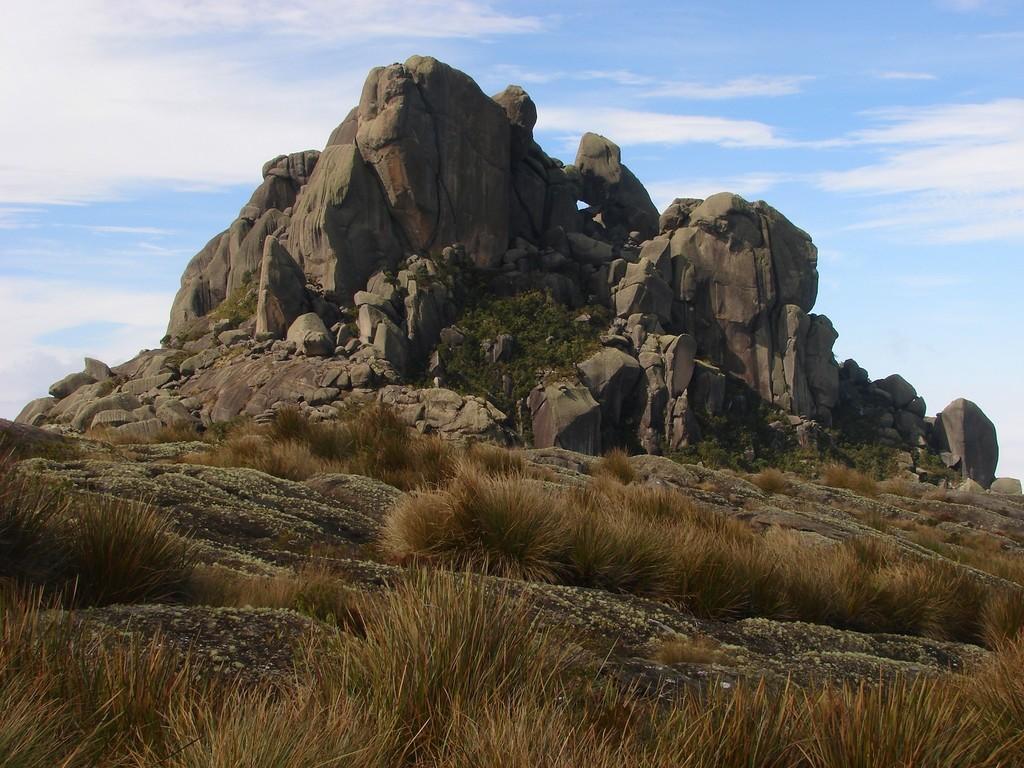Describe this image in one or two sentences. In this image we can see rocks, ground, shrubs and sky with clouds in the background. 